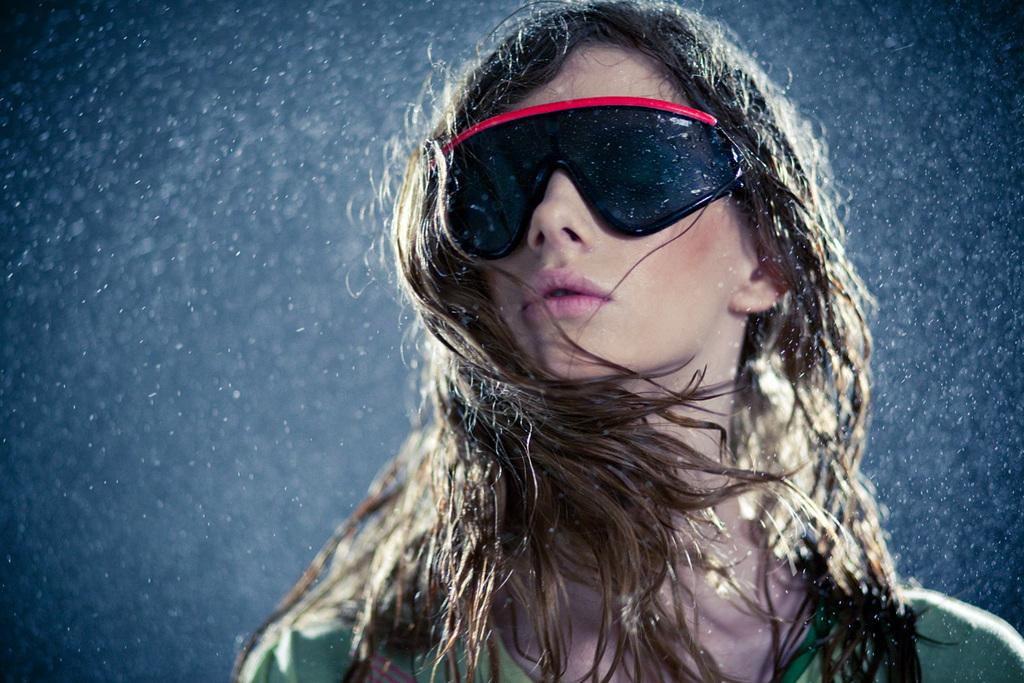Who is present in the image? There is a woman in the image. What is the woman wearing in the image? The woman is wearing spectacles in the image. Can you describe any other details visible in the image? There are water drops visible in the image. What type of art can be seen on the road in the image? There is no road or art present in the image; it features a woman wearing spectacles and water drops. What medical advice can the doctor provide in the image? There is no doctor present in the image, so it is not possible to determine what medical advice they might provide. 